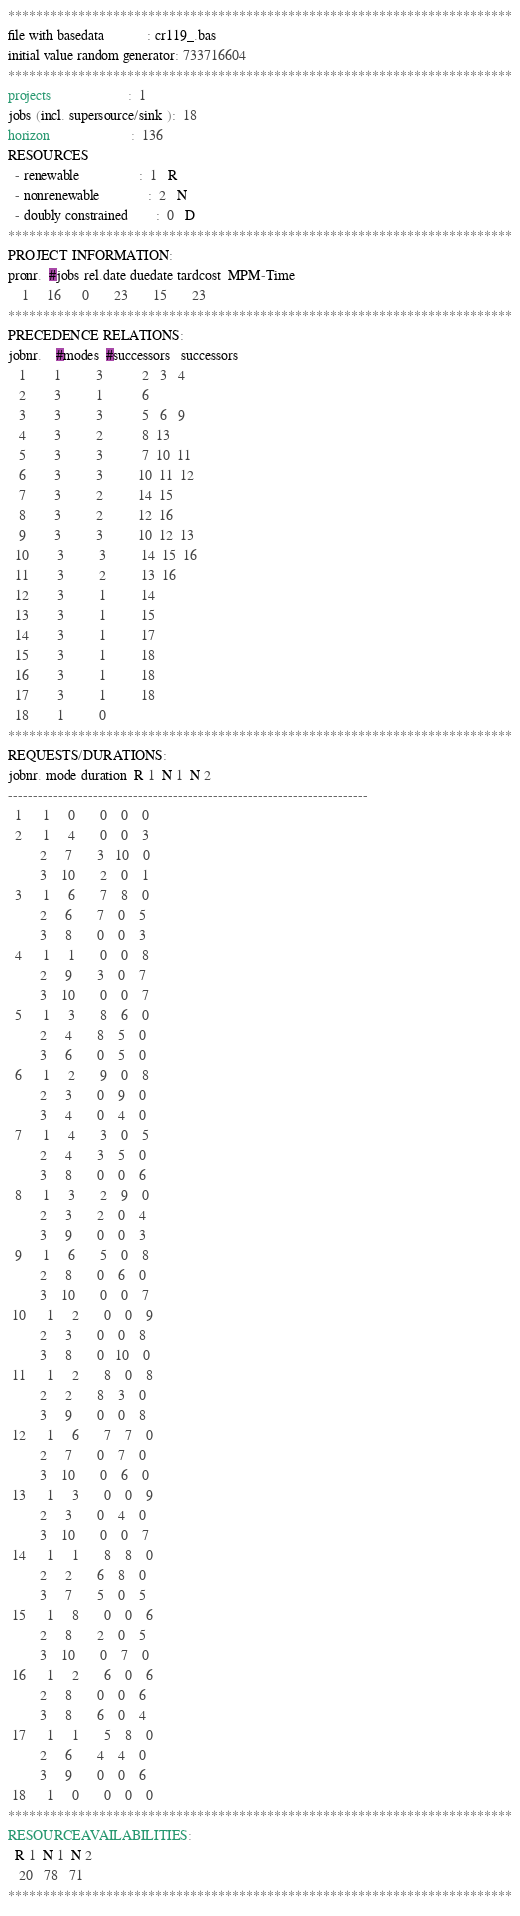<code> <loc_0><loc_0><loc_500><loc_500><_ObjectiveC_>************************************************************************
file with basedata            : cr119_.bas
initial value random generator: 733716604
************************************************************************
projects                      :  1
jobs (incl. supersource/sink ):  18
horizon                       :  136
RESOURCES
  - renewable                 :  1   R
  - nonrenewable              :  2   N
  - doubly constrained        :  0   D
************************************************************************
PROJECT INFORMATION:
pronr.  #jobs rel.date duedate tardcost  MPM-Time
    1     16      0       23       15       23
************************************************************************
PRECEDENCE RELATIONS:
jobnr.    #modes  #successors   successors
   1        1          3           2   3   4
   2        3          1           6
   3        3          3           5   6   9
   4        3          2           8  13
   5        3          3           7  10  11
   6        3          3          10  11  12
   7        3          2          14  15
   8        3          2          12  16
   9        3          3          10  12  13
  10        3          3          14  15  16
  11        3          2          13  16
  12        3          1          14
  13        3          1          15
  14        3          1          17
  15        3          1          18
  16        3          1          18
  17        3          1          18
  18        1          0        
************************************************************************
REQUESTS/DURATIONS:
jobnr. mode duration  R 1  N 1  N 2
------------------------------------------------------------------------
  1      1     0       0    0    0
  2      1     4       0    0    3
         2     7       3   10    0
         3    10       2    0    1
  3      1     6       7    8    0
         2     6       7    0    5
         3     8       0    0    3
  4      1     1       0    0    8
         2     9       3    0    7
         3    10       0    0    7
  5      1     3       8    6    0
         2     4       8    5    0
         3     6       0    5    0
  6      1     2       9    0    8
         2     3       0    9    0
         3     4       0    4    0
  7      1     4       3    0    5
         2     4       3    5    0
         3     8       0    0    6
  8      1     3       2    9    0
         2     3       2    0    4
         3     9       0    0    3
  9      1     6       5    0    8
         2     8       0    6    0
         3    10       0    0    7
 10      1     2       0    0    9
         2     3       0    0    8
         3     8       0   10    0
 11      1     2       8    0    8
         2     2       8    3    0
         3     9       0    0    8
 12      1     6       7    7    0
         2     7       0    7    0
         3    10       0    6    0
 13      1     3       0    0    9
         2     3       0    4    0
         3    10       0    0    7
 14      1     1       8    8    0
         2     2       6    8    0
         3     7       5    0    5
 15      1     8       0    0    6
         2     8       2    0    5
         3    10       0    7    0
 16      1     2       6    0    6
         2     8       0    0    6
         3     8       6    0    4
 17      1     1       5    8    0
         2     6       4    4    0
         3     9       0    0    6
 18      1     0       0    0    0
************************************************************************
RESOURCEAVAILABILITIES:
  R 1  N 1  N 2
   20   78   71
************************************************************************
</code> 